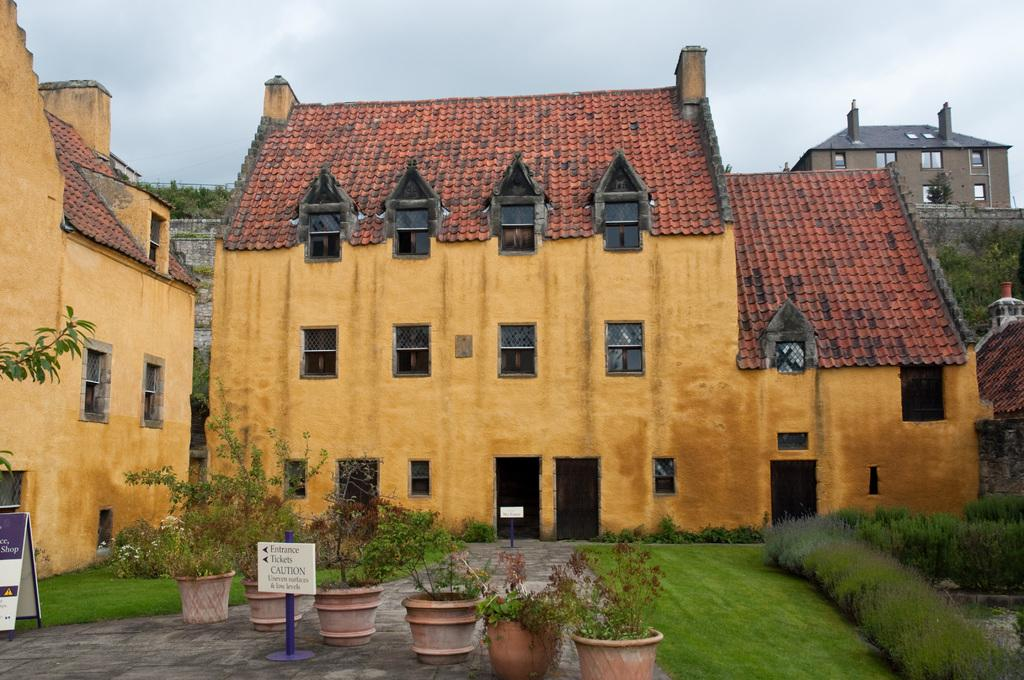What type of structures can be seen in the image? There are buildings in the image. What architectural features are visible on the buildings? There are windows and at least one door visible on the buildings. What additional elements can be seen in the image? There are boards with text, plants, trees, grass, and flowers in the image. What is visible in the background of the image? The sky is visible in the image. Can you hear the ghost coughing in the image? There is no ghost or coughing sound present in the image; it only contains visual elements. 